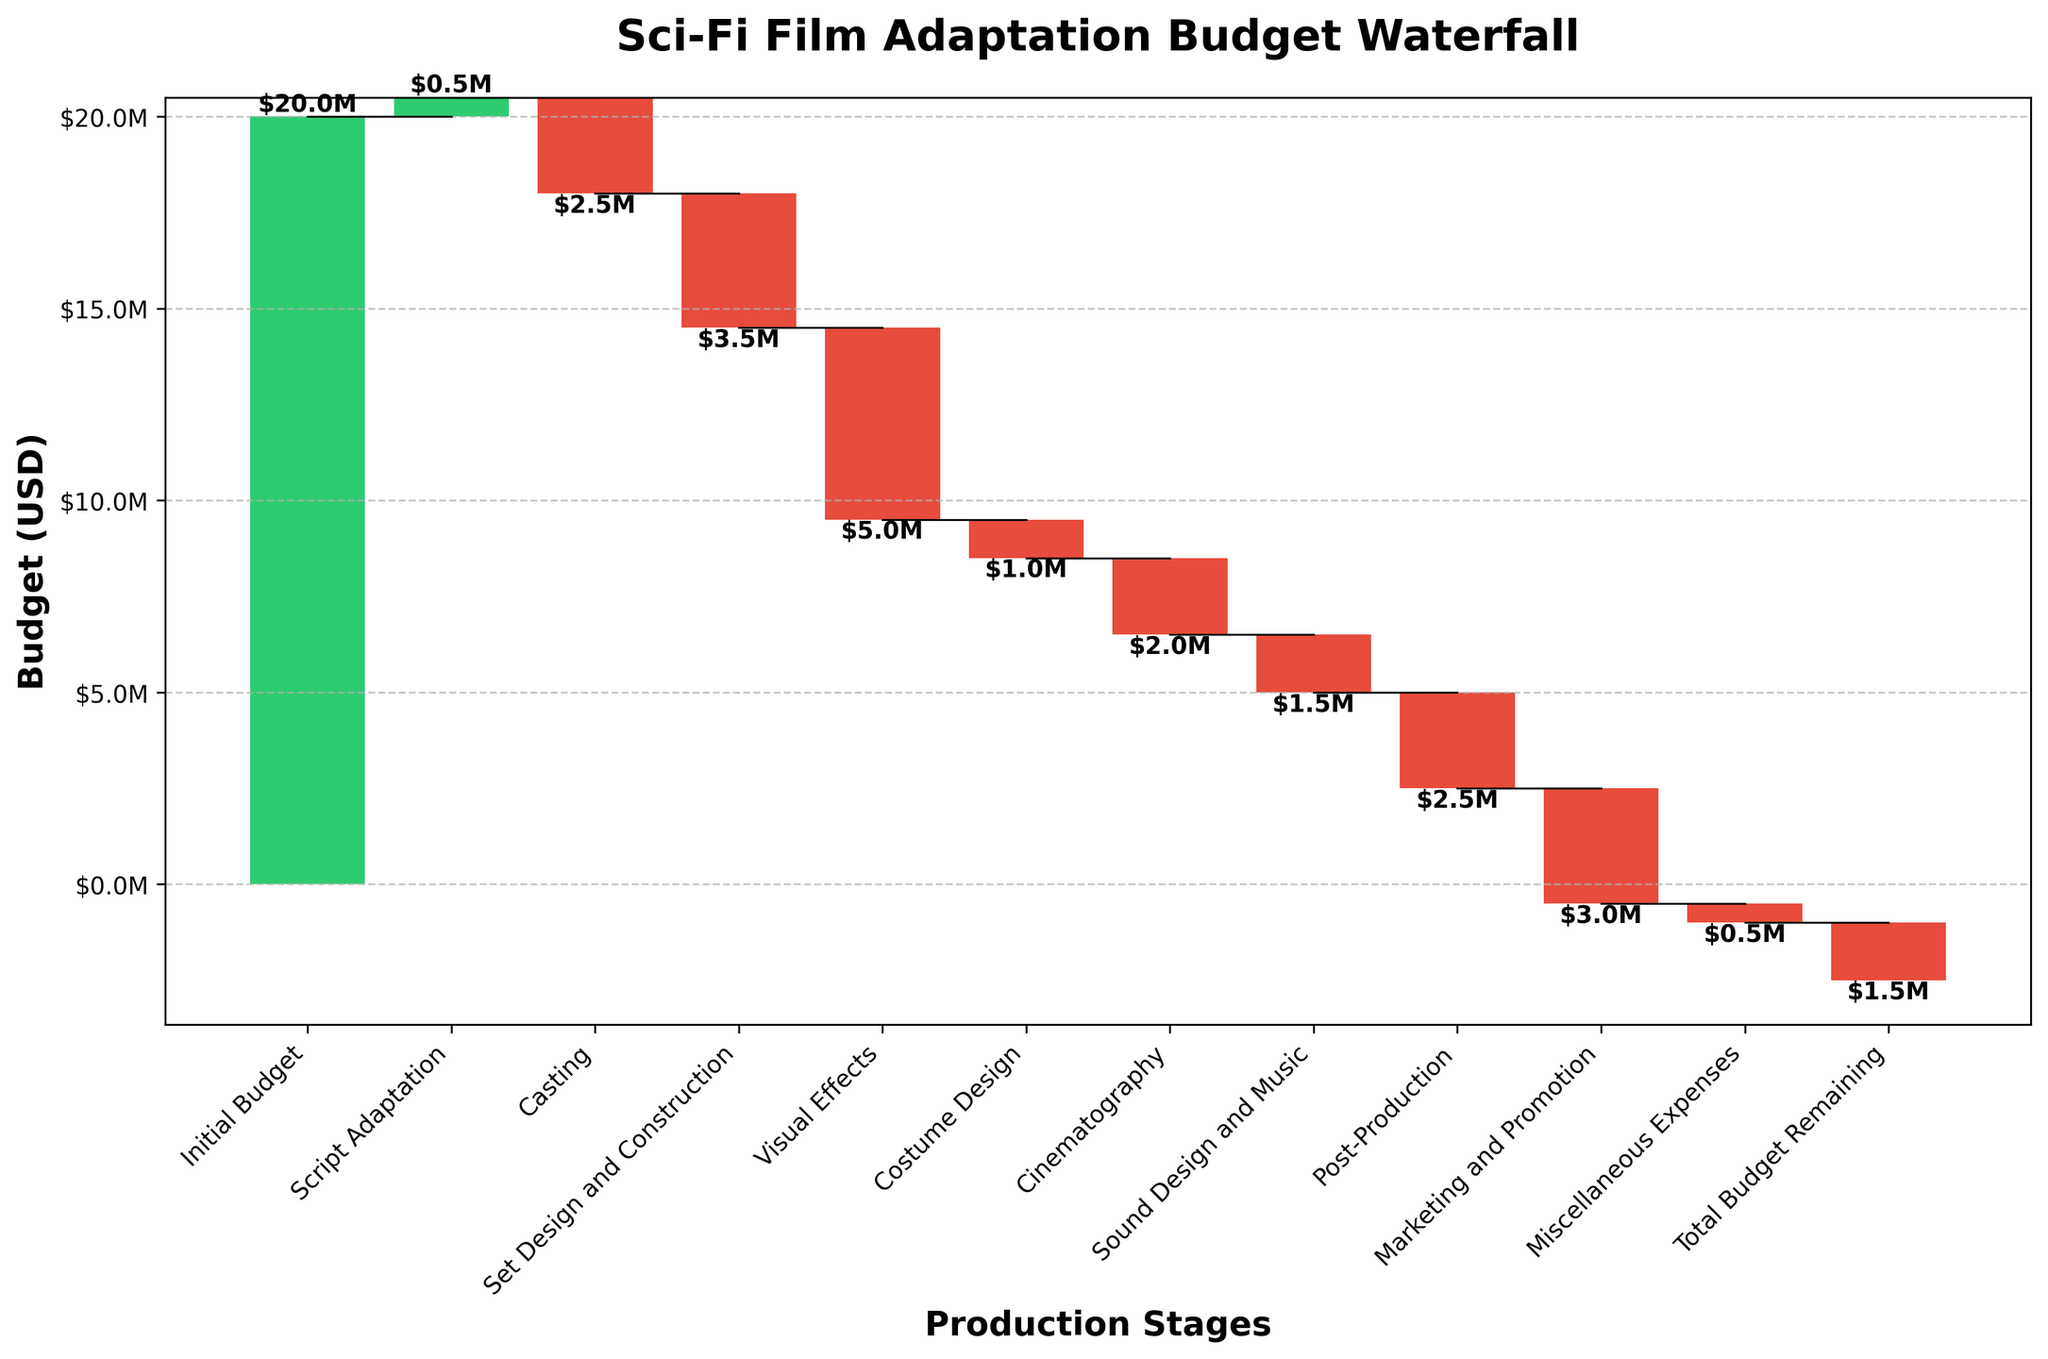What is the title of the figure? The title of the figure is written at the top center in bold text.
Answer: Sci-Fi Film Adaptation Budget Waterfall Which stage incurs the highest cost in the budget? The highest cost in the budget can be identified by the longest red bar pointing downwards.
Answer: Visual Effects How much of the budget remains after accounting for Visual Effects? The cumulative value right after the Visual Effects expense is the amount remaining. The cumulative value shown is right below the "Cinematography" stage.
Answer: $8.5M What is the total cost for Casting and Set Design and Construction? Add the values represented by the red bars for "Casting" and "Set Design and Construction".
Answer: $6.5M By how much does Marketing and Promotion exceed Costume Design? Subtract the value of Costume Design (1M) from Marketing and Promotion (3M).
Answer: $2M What is the cumulative budget remaining after Post-Production? The cumulative budget remaining after Post-Production can be observed by summing the segments up to "Post-Production". Alternatively, it can be seen within the bar and text near the "Total Budget Remaining".
Answer: $-1.5M Between Initial Budget and Script Adaptation, which has a higher value, and by how much? Compare the bar height (green for positive values) between "Initial Budget" and "Script Adaptation" and subtract the latter from the former.
Answer: Initial Budget by $19.5M What percentage of the Initial Budget does the Sound Design and Music stage represent? Divide the cost of the "Sound Design and Music" by the "Initial Budget" and then multiply by 100 to get the percentage.
Answer: 7.5% Which production stage comes immediately before the Marketing and Promotion stage? Identify the category directly preceding "Marketing and Promotion" by looking at the position on the x-axis.
Answer: Post-Production Is the final project under or over budget? How can you tell? The final project status can be identified by looking at the "Total Budget Remaining" at the end of the plot and seeing if it is a positive or negative value.
Answer: Over budget by $1.5M 